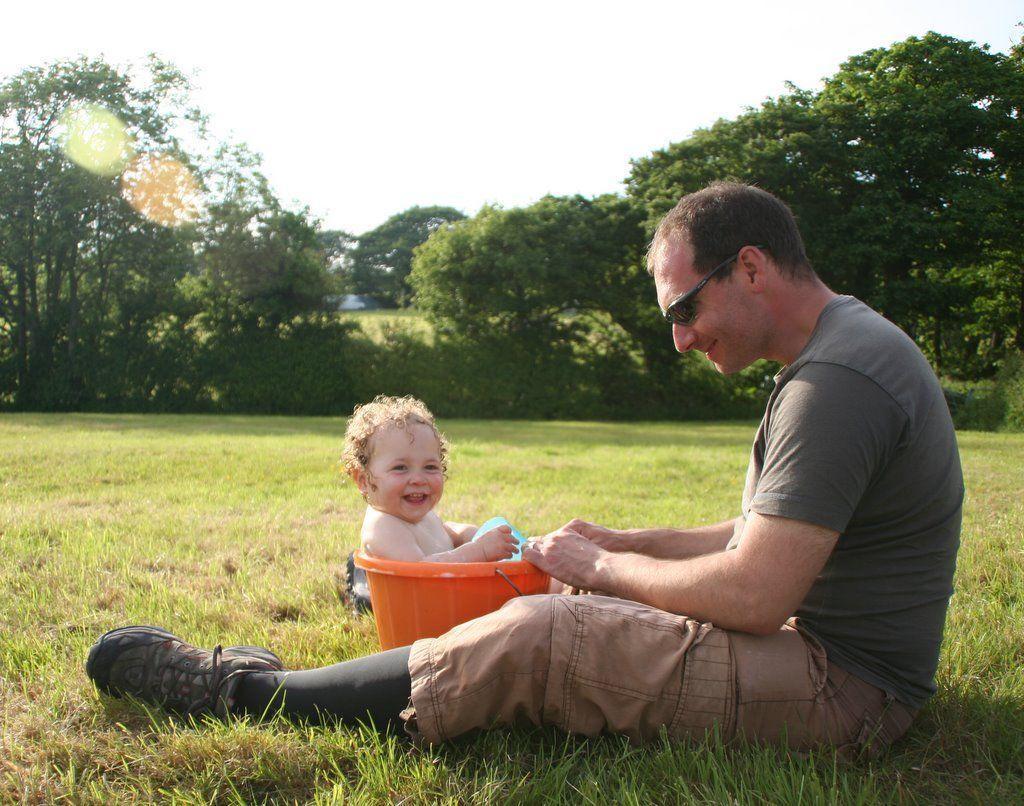Can you describe this image briefly? This image is clicked in a garden. There is a man and kid. The kid is sitting in the bucket and laughing. The man is wearing black shirt. In the background, there are leaves and sky. At the bottom there is green grass. 